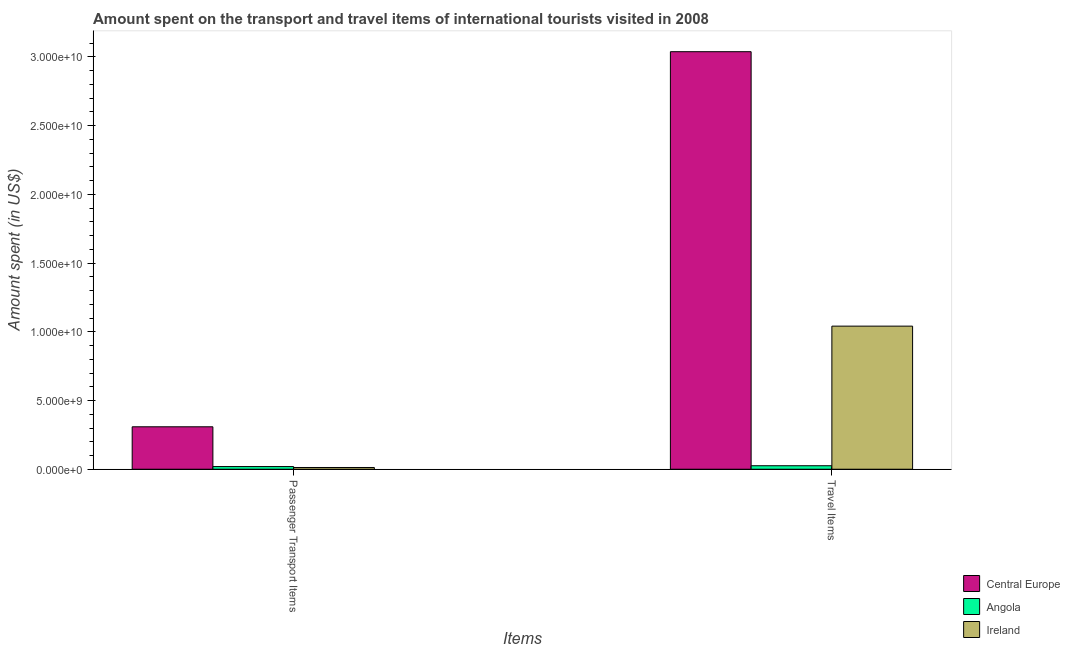How many different coloured bars are there?
Your answer should be very brief. 3. How many groups of bars are there?
Your answer should be compact. 2. Are the number of bars per tick equal to the number of legend labels?
Keep it short and to the point. Yes. What is the label of the 2nd group of bars from the left?
Offer a very short reply. Travel Items. What is the amount spent in travel items in Central Europe?
Offer a terse response. 3.04e+1. Across all countries, what is the maximum amount spent in travel items?
Your answer should be compact. 3.04e+1. Across all countries, what is the minimum amount spent on passenger transport items?
Provide a succinct answer. 1.26e+08. In which country was the amount spent in travel items maximum?
Offer a terse response. Central Europe. In which country was the amount spent on passenger transport items minimum?
Your answer should be compact. Ireland. What is the total amount spent in travel items in the graph?
Provide a short and direct response. 4.11e+1. What is the difference between the amount spent on passenger transport items in Ireland and that in Angola?
Offer a terse response. -6.70e+07. What is the difference between the amount spent on passenger transport items in Ireland and the amount spent in travel items in Central Europe?
Provide a succinct answer. -3.03e+1. What is the average amount spent in travel items per country?
Provide a short and direct response. 1.37e+1. What is the difference between the amount spent in travel items and amount spent on passenger transport items in Central Europe?
Your answer should be very brief. 2.73e+1. What is the ratio of the amount spent on passenger transport items in Angola to that in Ireland?
Your response must be concise. 1.53. In how many countries, is the amount spent in travel items greater than the average amount spent in travel items taken over all countries?
Keep it short and to the point. 1. What does the 2nd bar from the left in Travel Items represents?
Give a very brief answer. Angola. What does the 2nd bar from the right in Travel Items represents?
Keep it short and to the point. Angola. Are all the bars in the graph horizontal?
Give a very brief answer. No. How many countries are there in the graph?
Provide a succinct answer. 3. Are the values on the major ticks of Y-axis written in scientific E-notation?
Your answer should be very brief. Yes. Does the graph contain any zero values?
Offer a terse response. No. Where does the legend appear in the graph?
Offer a very short reply. Bottom right. How are the legend labels stacked?
Your answer should be compact. Vertical. What is the title of the graph?
Provide a succinct answer. Amount spent on the transport and travel items of international tourists visited in 2008. Does "East Asia (developing only)" appear as one of the legend labels in the graph?
Your answer should be compact. No. What is the label or title of the X-axis?
Offer a terse response. Items. What is the label or title of the Y-axis?
Offer a terse response. Amount spent (in US$). What is the Amount spent (in US$) in Central Europe in Passenger Transport Items?
Keep it short and to the point. 3.09e+09. What is the Amount spent (in US$) of Angola in Passenger Transport Items?
Make the answer very short. 1.93e+08. What is the Amount spent (in US$) in Ireland in Passenger Transport Items?
Your answer should be very brief. 1.26e+08. What is the Amount spent (in US$) of Central Europe in Travel Items?
Your response must be concise. 3.04e+1. What is the Amount spent (in US$) in Angola in Travel Items?
Ensure brevity in your answer.  2.54e+08. What is the Amount spent (in US$) in Ireland in Travel Items?
Offer a terse response. 1.04e+1. Across all Items, what is the maximum Amount spent (in US$) of Central Europe?
Your response must be concise. 3.04e+1. Across all Items, what is the maximum Amount spent (in US$) of Angola?
Ensure brevity in your answer.  2.54e+08. Across all Items, what is the maximum Amount spent (in US$) in Ireland?
Offer a very short reply. 1.04e+1. Across all Items, what is the minimum Amount spent (in US$) of Central Europe?
Ensure brevity in your answer.  3.09e+09. Across all Items, what is the minimum Amount spent (in US$) of Angola?
Your answer should be very brief. 1.93e+08. Across all Items, what is the minimum Amount spent (in US$) in Ireland?
Offer a very short reply. 1.26e+08. What is the total Amount spent (in US$) in Central Europe in the graph?
Your answer should be very brief. 3.35e+1. What is the total Amount spent (in US$) in Angola in the graph?
Provide a succinct answer. 4.47e+08. What is the total Amount spent (in US$) of Ireland in the graph?
Your response must be concise. 1.05e+1. What is the difference between the Amount spent (in US$) in Central Europe in Passenger Transport Items and that in Travel Items?
Offer a very short reply. -2.73e+1. What is the difference between the Amount spent (in US$) of Angola in Passenger Transport Items and that in Travel Items?
Make the answer very short. -6.10e+07. What is the difference between the Amount spent (in US$) of Ireland in Passenger Transport Items and that in Travel Items?
Offer a terse response. -1.03e+1. What is the difference between the Amount spent (in US$) in Central Europe in Passenger Transport Items and the Amount spent (in US$) in Angola in Travel Items?
Ensure brevity in your answer.  2.83e+09. What is the difference between the Amount spent (in US$) of Central Europe in Passenger Transport Items and the Amount spent (in US$) of Ireland in Travel Items?
Offer a terse response. -7.32e+09. What is the difference between the Amount spent (in US$) of Angola in Passenger Transport Items and the Amount spent (in US$) of Ireland in Travel Items?
Your answer should be very brief. -1.02e+1. What is the average Amount spent (in US$) of Central Europe per Items?
Your answer should be very brief. 1.67e+1. What is the average Amount spent (in US$) in Angola per Items?
Your response must be concise. 2.24e+08. What is the average Amount spent (in US$) of Ireland per Items?
Offer a terse response. 5.27e+09. What is the difference between the Amount spent (in US$) in Central Europe and Amount spent (in US$) in Angola in Passenger Transport Items?
Provide a succinct answer. 2.90e+09. What is the difference between the Amount spent (in US$) of Central Europe and Amount spent (in US$) of Ireland in Passenger Transport Items?
Offer a terse response. 2.96e+09. What is the difference between the Amount spent (in US$) in Angola and Amount spent (in US$) in Ireland in Passenger Transport Items?
Your response must be concise. 6.70e+07. What is the difference between the Amount spent (in US$) in Central Europe and Amount spent (in US$) in Angola in Travel Items?
Offer a very short reply. 3.01e+1. What is the difference between the Amount spent (in US$) of Central Europe and Amount spent (in US$) of Ireland in Travel Items?
Keep it short and to the point. 2.00e+1. What is the difference between the Amount spent (in US$) in Angola and Amount spent (in US$) in Ireland in Travel Items?
Give a very brief answer. -1.02e+1. What is the ratio of the Amount spent (in US$) in Central Europe in Passenger Transport Items to that in Travel Items?
Keep it short and to the point. 0.1. What is the ratio of the Amount spent (in US$) of Angola in Passenger Transport Items to that in Travel Items?
Your response must be concise. 0.76. What is the ratio of the Amount spent (in US$) of Ireland in Passenger Transport Items to that in Travel Items?
Ensure brevity in your answer.  0.01. What is the difference between the highest and the second highest Amount spent (in US$) of Central Europe?
Provide a succinct answer. 2.73e+1. What is the difference between the highest and the second highest Amount spent (in US$) in Angola?
Your response must be concise. 6.10e+07. What is the difference between the highest and the second highest Amount spent (in US$) in Ireland?
Your answer should be compact. 1.03e+1. What is the difference between the highest and the lowest Amount spent (in US$) of Central Europe?
Ensure brevity in your answer.  2.73e+1. What is the difference between the highest and the lowest Amount spent (in US$) in Angola?
Your answer should be very brief. 6.10e+07. What is the difference between the highest and the lowest Amount spent (in US$) in Ireland?
Give a very brief answer. 1.03e+1. 